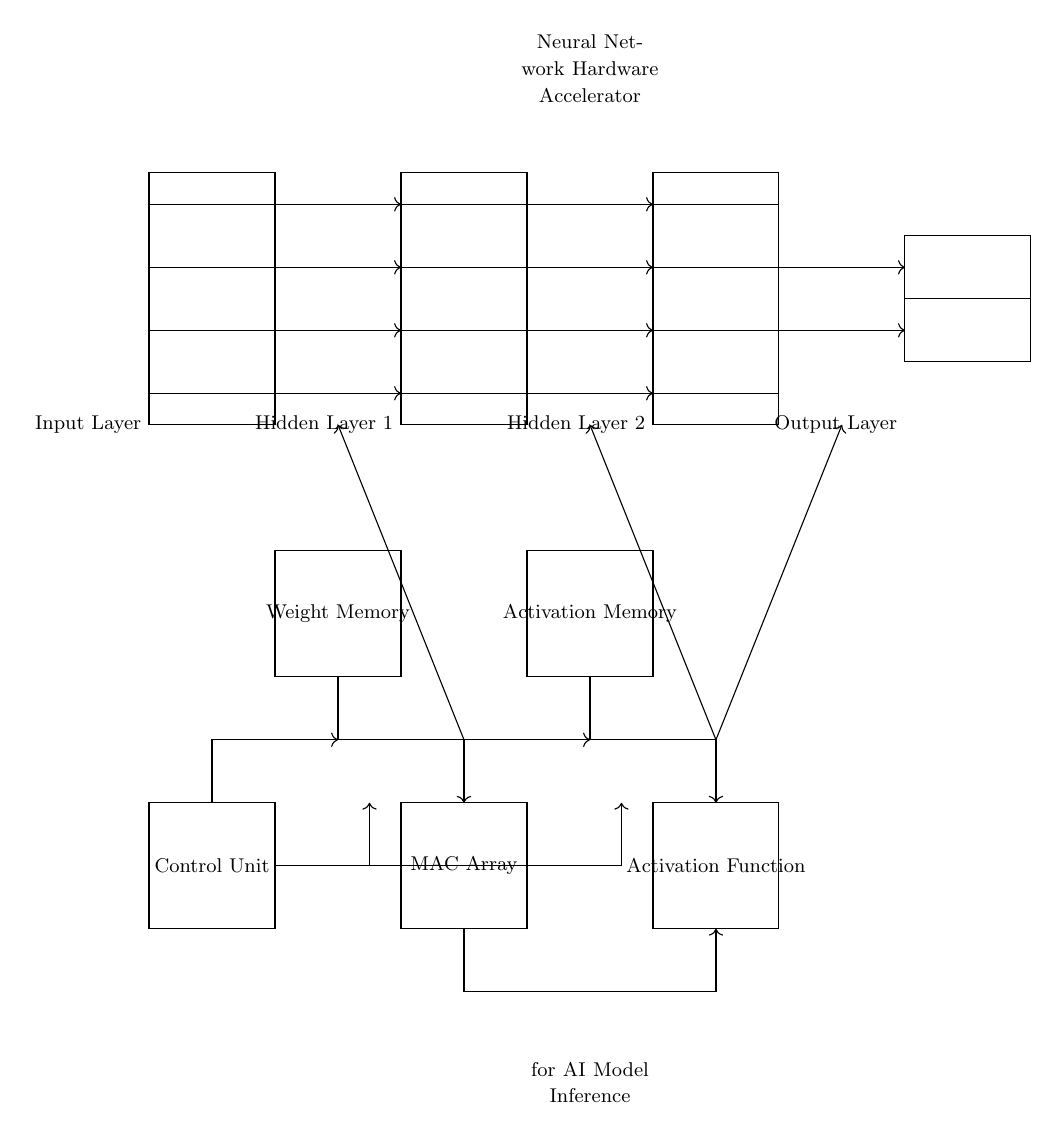What are the components of the input layer? The input layer consists of a rectangle containing four input lines, representing different input neurons. These lines connect to the hidden layer, indicating the flow of information.
Answer: Four input lines What is the function of the MAC array in this circuit? The MAC array, or Multiply-Accumulate array, is responsible for performing the multiplication and accumulation of input data with the weights during the inference process. This enables the calculation of neuron activations.
Answer: Multiplication and accumulation How many hidden layers are present in this circuit? The circuit diagram clearly shows two distinct hidden layers between the input and output layers, each represented by rectangles with input lines.
Answer: Two hidden layers Which unit is responsible for storing weights? The weight memory unit, located beneath the input layer, is specifically designed to store the weights used to generate neuron outputs during the model inference.
Answer: Weight memory What is the primary purpose of the activation function in the circuit? The activation function, shown in the second processing unit, applies a non-linear transformation to the outputs from the MAC array, allowing the network to learn complex relationships. This is essential for enhancing model performance.
Answer: Non-linear transformation How do signals flow from the output layer to the processing units? The signals flow through specific connections: outputs from the last hidden layer send their activations to the output layer through directed arrows, indicating the progression of data through the circuit for final output calculation.
Answer: Through directed connections What role does the control unit play in this neural network hardware accelerator? The control unit manages the overall operation of the circuit by coordinating the flow of data between different units, such as the processing units and memory. It signals when to read from memory or perform calculations, ensuring synchronized functioning.
Answer: Coordination of operations 